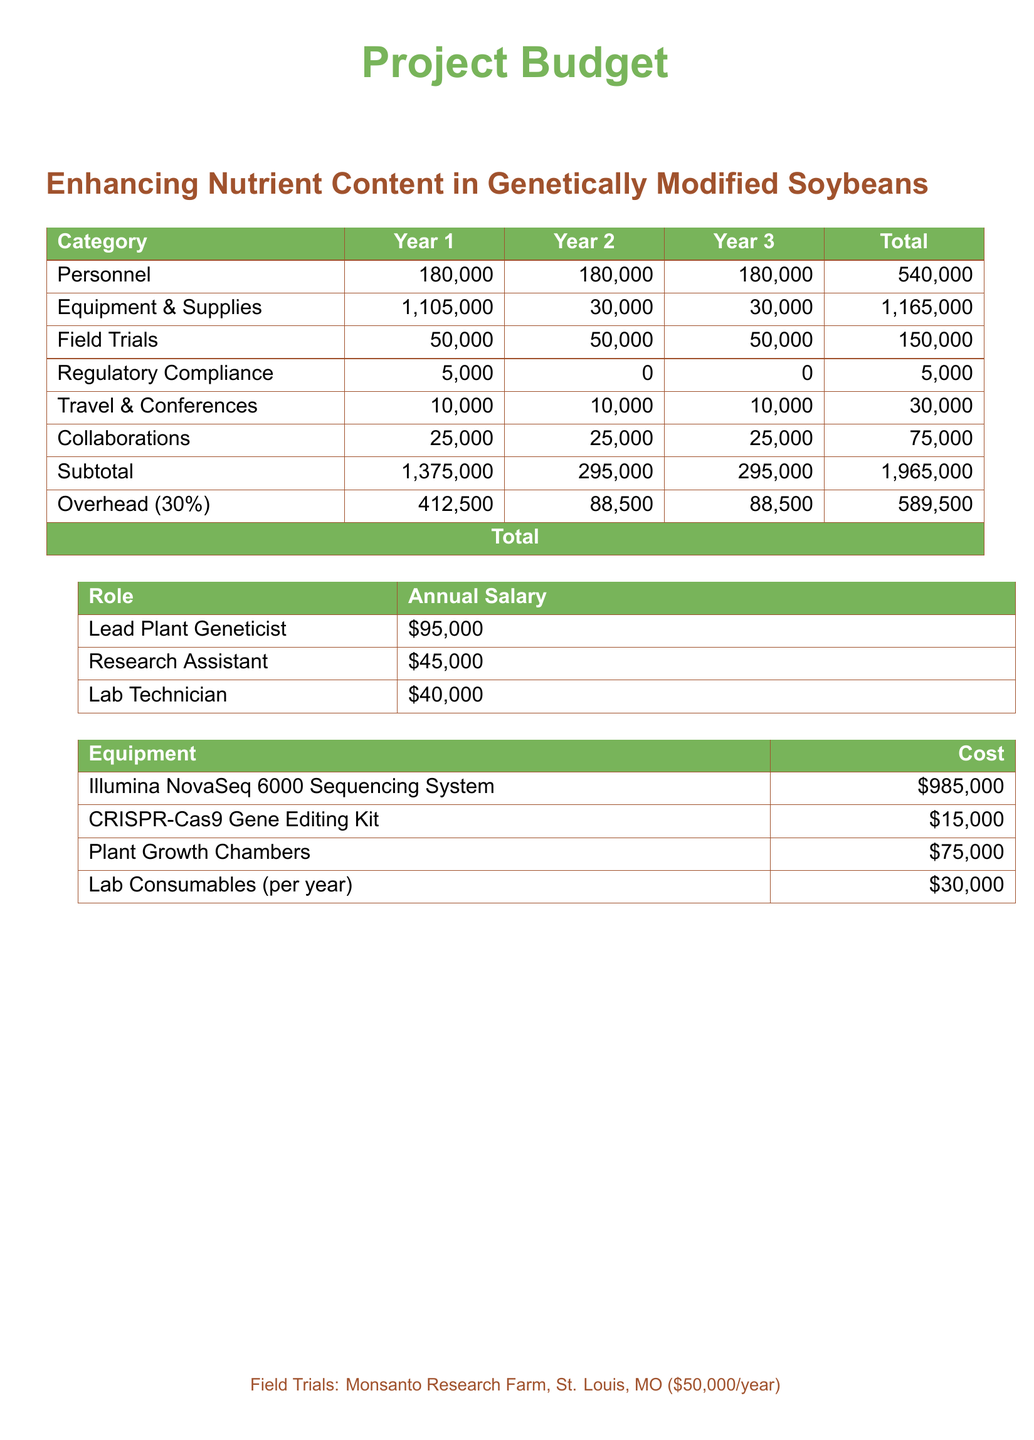What is the total budget for the project? The total budget is calculated by adding all expenses across the three years, resulting in $2,554,500.
Answer: $2,554,500 How much is allocated for personnel each year? According to the budget, the personnel costs are consistent at $180,000 for each of the three years.
Answer: $180,000 What is the cost of the Illumina NovaSeq 6000 Sequencing System? The document specifies that this piece of equipment costs $985,000.
Answer: $985,000 What is the total cost for regulatory compliance over three years? The budget outlines a total cost of $5,000 for regulatory compliance.
Answer: $5,000 How much are the field trials expected to cost in total? The budget indicates that field trials will cost $50,000 each year, totaling $150,000 over three years.
Answer: $150,000 What percentage is the overhead added to the subtotal? The budget states that overhead is calculated at 30% of the subtotal.
Answer: 30% What is the annual salary of the Lead Plant Geneticist? The document details that the salary for the Lead Plant Geneticist is $95,000 per year.
Answer: $95,000 What is the cost per year for lab consumables? The budget mentions that lab consumables will cost $30,000 each year.
Answer: $30,000 How much is budgeted for travel and conferences over the three years? The budget indicates $10,000 per year for travel and conferences, summing to $30,000 overall.
Answer: $30,000 